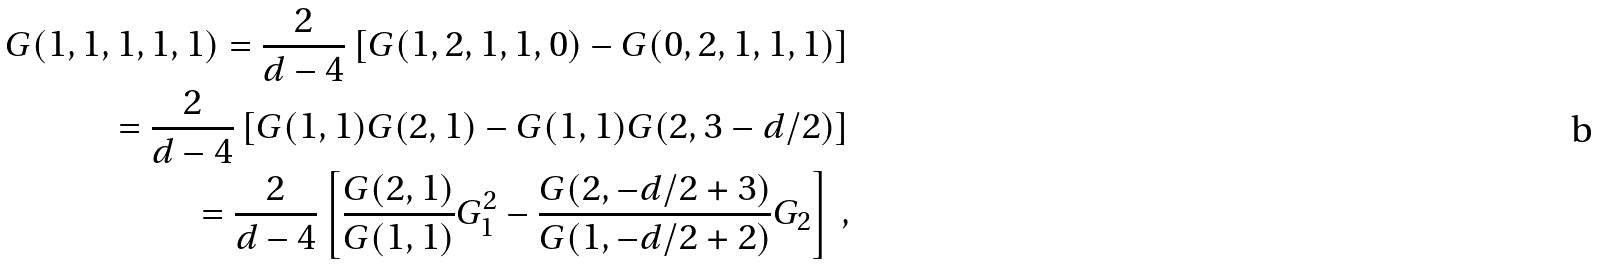Convert formula to latex. <formula><loc_0><loc_0><loc_500><loc_500>G ( 1 , 1 , 1 , 1 , 1 ) = \frac { 2 } { d - 4 } \left [ G ( 1 , 2 , 1 , 1 , 0 ) - G ( 0 , 2 , 1 , 1 , 1 ) \right ] \\ = \frac { 2 } { d - 4 } \left [ G ( 1 , 1 ) G ( 2 , 1 ) - G ( 1 , 1 ) G ( 2 , 3 - d / 2 ) \right ] \\ = \frac { 2 } { d - 4 } \left [ \frac { G ( 2 , 1 ) } { G ( 1 , 1 ) } G _ { 1 } ^ { 2 } - \frac { G ( 2 , - d / 2 + 3 ) } { G ( 1 , - d / 2 + 2 ) } G _ { 2 } \right ] \, ,</formula> 